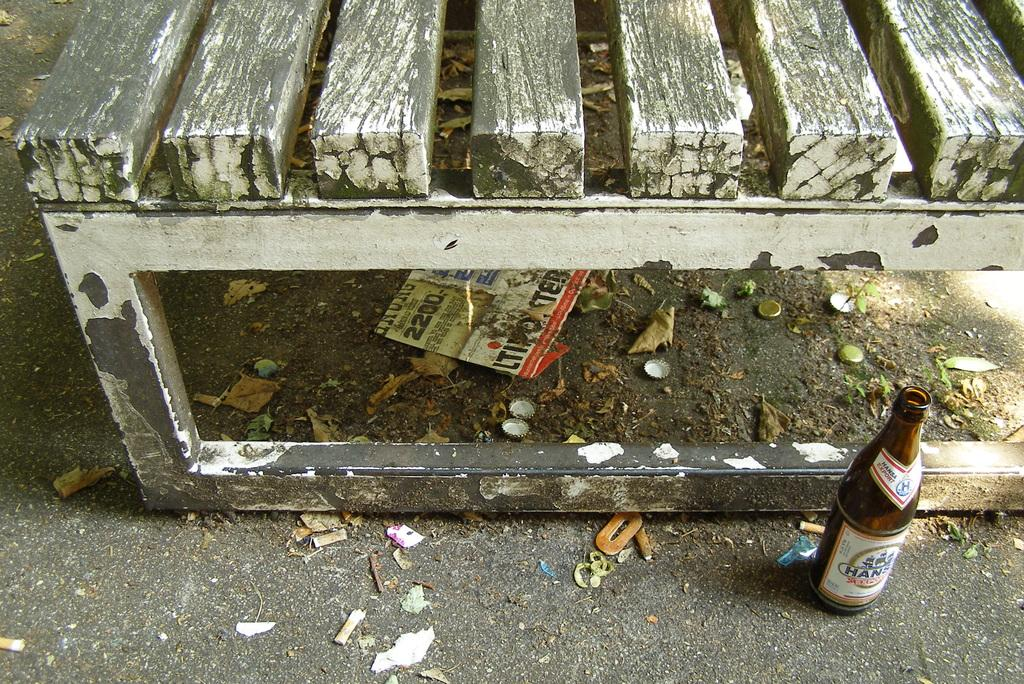What is located under the bench in the image? There is a paper, bottle caps, and dry leaves under the bench. What else can be seen beside the bench in the image? There is a bottle with a sticker beside the bench. How does the ladybug contribute to the division of the paper under the bench? There is no ladybug present in the image, so it cannot contribute to the division of the paper. 